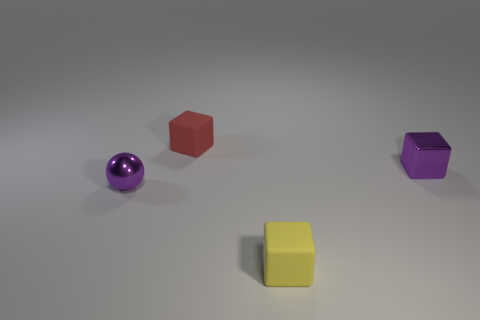What material do the objects in the image appear to be made of? The objects in the image seem to be made of a solid material with a smooth surface, possibly plastic or a polished metal, given their reflective properties and sharp edges. How does the lighting affect the appearance of the objects? The lighting in the image creates soft shadows and gentle reflections on the objects, enhancing their three-dimensional form and contributing to the overall muted and calm atmosphere. 